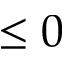Convert formula to latex. <formula><loc_0><loc_0><loc_500><loc_500>\leq 0</formula> 